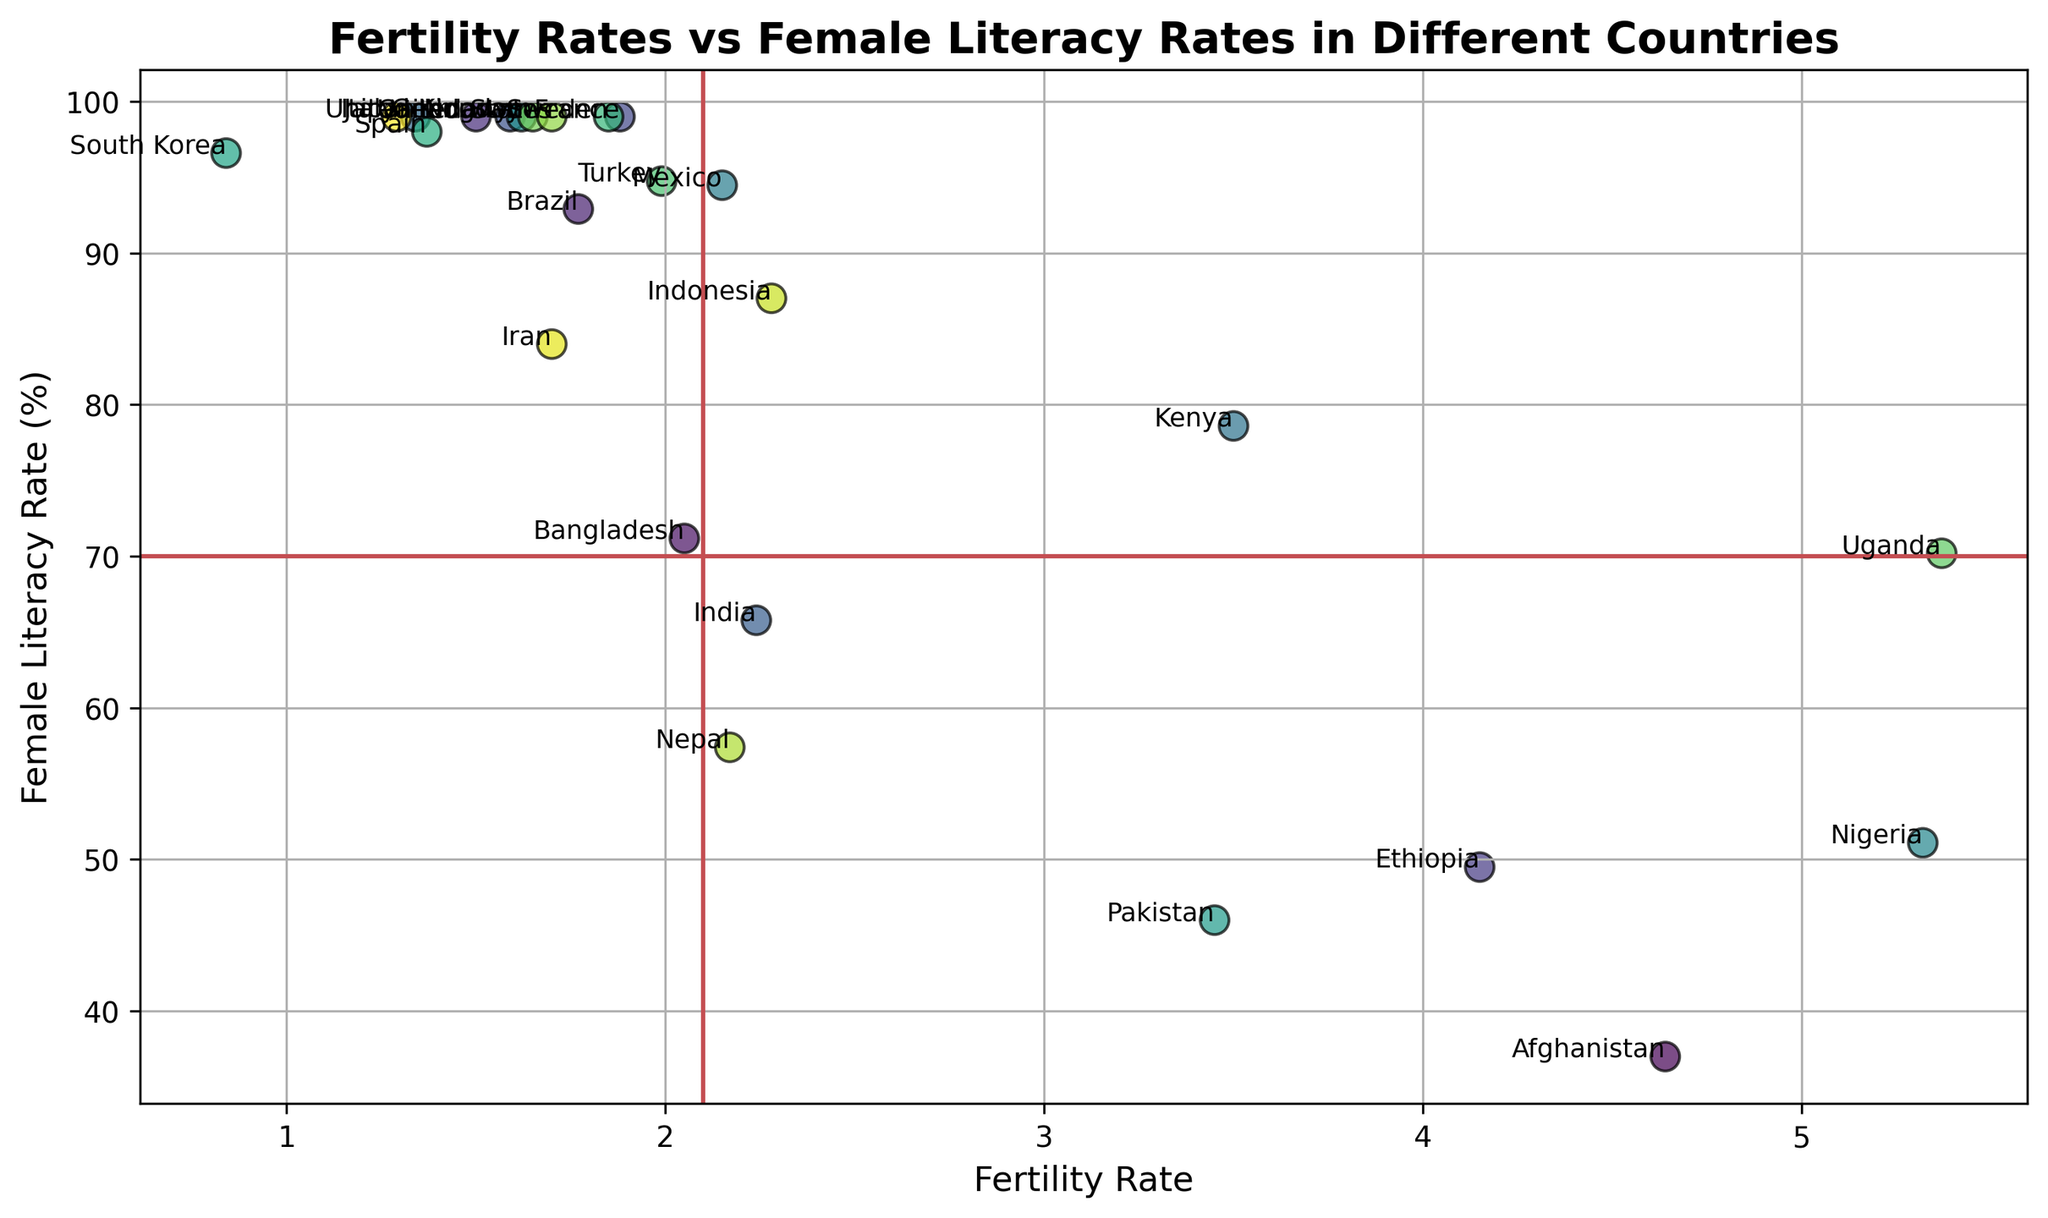Which country has the highest fertility rate, and what is its female literacy rate? The plot shows that Uganda has the highest fertility rate. To find its literacy rate, locate Uganda's point on the vertical axis.
Answer: 5.37, 70.20 Which country has the lowest female literacy rate, and what is its fertility rate? Locate the country with the lowest point on the vertical axis, which is Afghanistan. Then, identify its fertility rate from the plot.
Answer: 37.00, 4.64 How many countries have a fertility rate below 2 and a female literacy rate above 90%? Look for points to the left of the x=2 line and above the y=90 line. Count the applicable points: Brazil, Canada, Germany, Italy, South Korea, Spain, Sweden, United Kingdom, United States.
Answer: 9 Compare the female literacy rates of Nigeria and Ethiopia. Which country has a higher rate and by how much? Find the points representing Nigeria and Ethiopia. Ethiopia's literacy rate is 49.50 while Nigeria's is 51.10. Subtract Ethiopia's rate from Nigeria's.
Answer: 1.60 Which countries have a fertility rate between 1.5 and 2.0 and a female literacy rate of exactly 99%? Locate points within the fertility range of 1.5-2.0 on the horizontal axis and find which of them are exactly at 99% on the vertical axis. The countries are Canada, France, Germany, Norway, Sweden, United Kingdom, and United States.
Answer: 7 What's the average fertility rate among countries with a female literacy rate below 50%? Identify countries below the y=50 line: Afghanistan, Pakistan. Calculate their average fertility rate: (4.64 + 3.45) / 2.
Answer: 4.045 Between Kenya and Indonesia, which country has a higher female literacy rate, and by how much? Locate Kenya and Indonesia on the vertical axis, with Kenya at 78.60 and Indonesia at 87.02. Subtract Kenya's rate from Indonesia's.
Answer: 8.42 Which country is an outlier with a fertility rate significantly lower than the rest? The plot shows South Korea with the lowest fertility rate far below any other country.
Answer: South Korea 